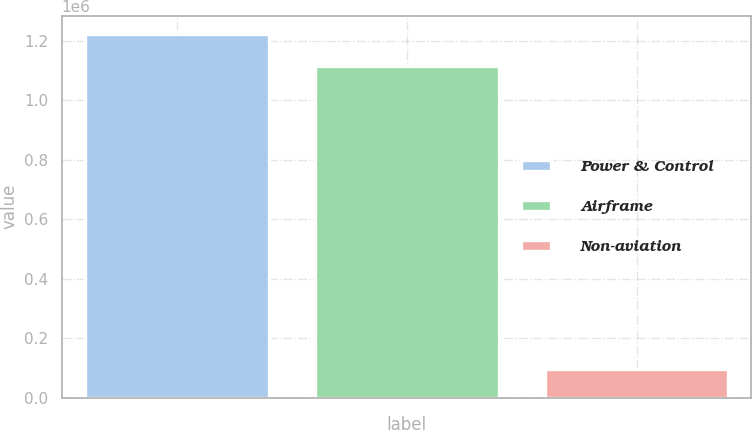<chart> <loc_0><loc_0><loc_500><loc_500><bar_chart><fcel>Power & Control<fcel>Airframe<fcel>Non-aviation<nl><fcel>1.22222e+06<fcel>1.11559e+06<fcel>95504<nl></chart> 